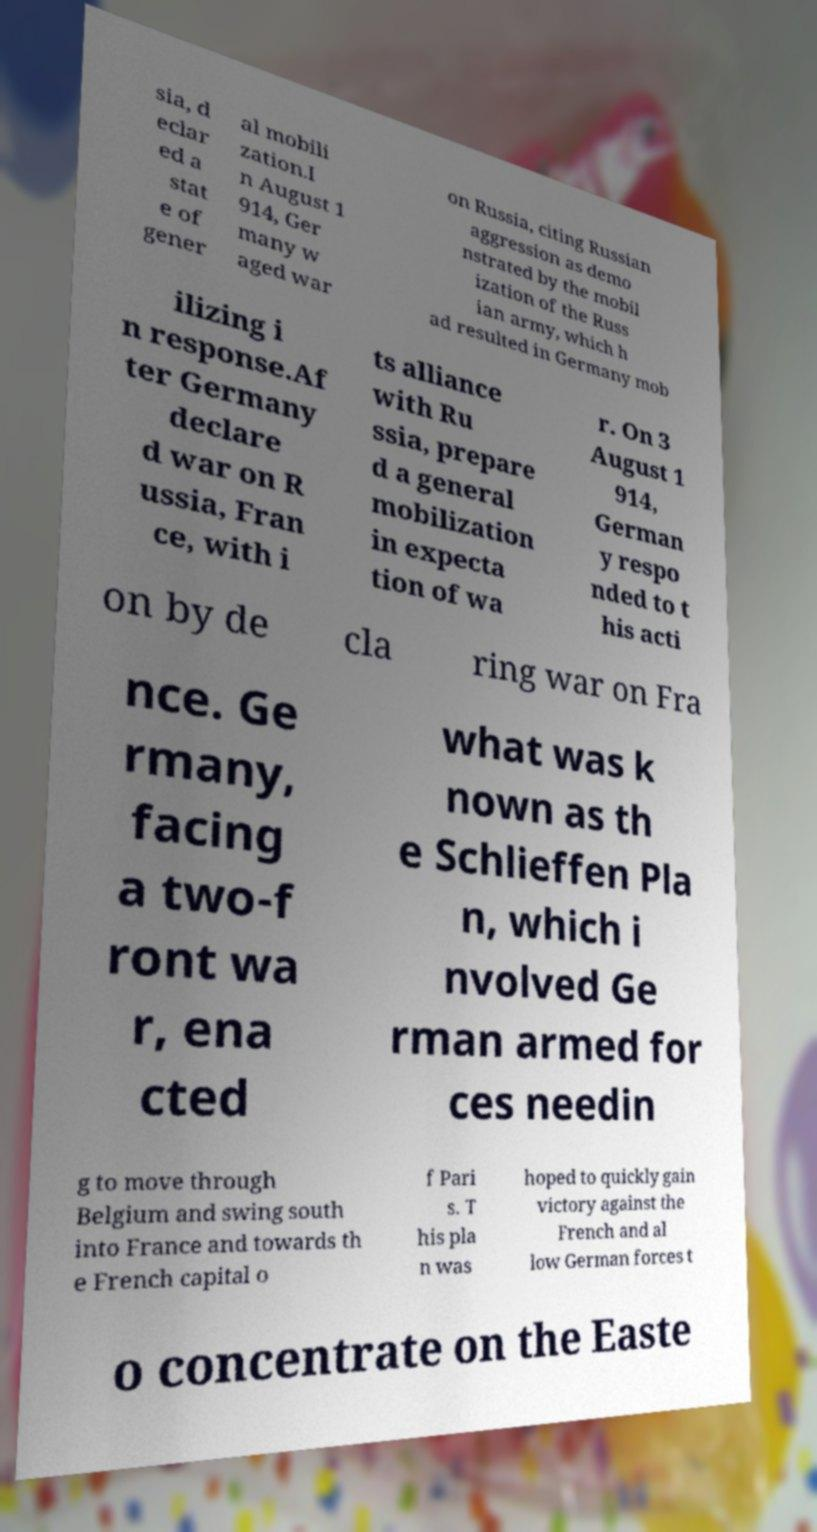What messages or text are displayed in this image? I need them in a readable, typed format. sia, d eclar ed a stat e of gener al mobili zation.I n August 1 914, Ger many w aged war on Russia, citing Russian aggression as demo nstrated by the mobil ization of the Russ ian army, which h ad resulted in Germany mob ilizing i n response.Af ter Germany declare d war on R ussia, Fran ce, with i ts alliance with Ru ssia, prepare d a general mobilization in expecta tion of wa r. On 3 August 1 914, German y respo nded to t his acti on by de cla ring war on Fra nce. Ge rmany, facing a two-f ront wa r, ena cted what was k nown as th e Schlieffen Pla n, which i nvolved Ge rman armed for ces needin g to move through Belgium and swing south into France and towards th e French capital o f Pari s. T his pla n was hoped to quickly gain victory against the French and al low German forces t o concentrate on the Easte 